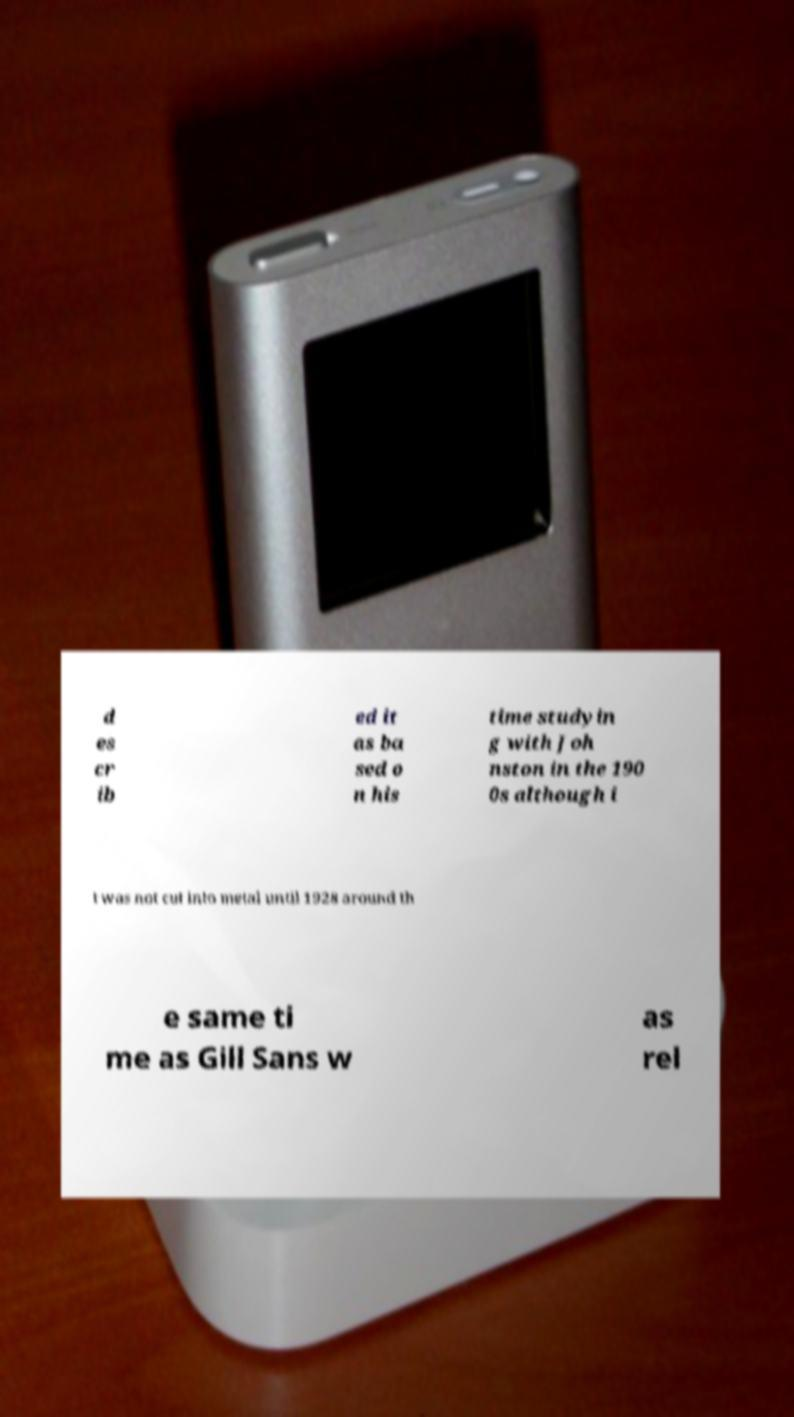Please identify and transcribe the text found in this image. d es cr ib ed it as ba sed o n his time studyin g with Joh nston in the 190 0s although i t was not cut into metal until 1928 around th e same ti me as Gill Sans w as rel 